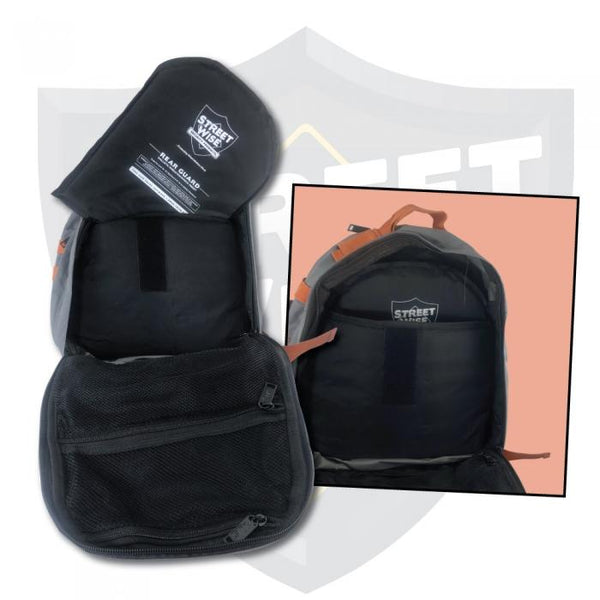How could this backpack's design be modified to cater specifically to adventure photographers? To cater specifically to adventure photographers, this backpack could be modified with several key features. Firstly, padded compartments with customizable dividers would be essential for safely carrying cameras, lenses, and other equipment. Dedicated pockets for memory cards, batteries, and other small accessories would add to the organization. The enhanced visibility features would be particularly beneficial for photographers working in various lighting conditions, ensuring they are seen when shooting in low-light environments. Additionally, waterproof fabric and sealed zippers would protect valuable gear from the elements. An external strap system could be added for attaching tripods or monopods, while a hydration bladder compartment could keep photographers hydrated during long shoots. Ventilated back panels and comfortable straps would also ensure that carrying heavy equipment over long distances is as comfortable as possible. 